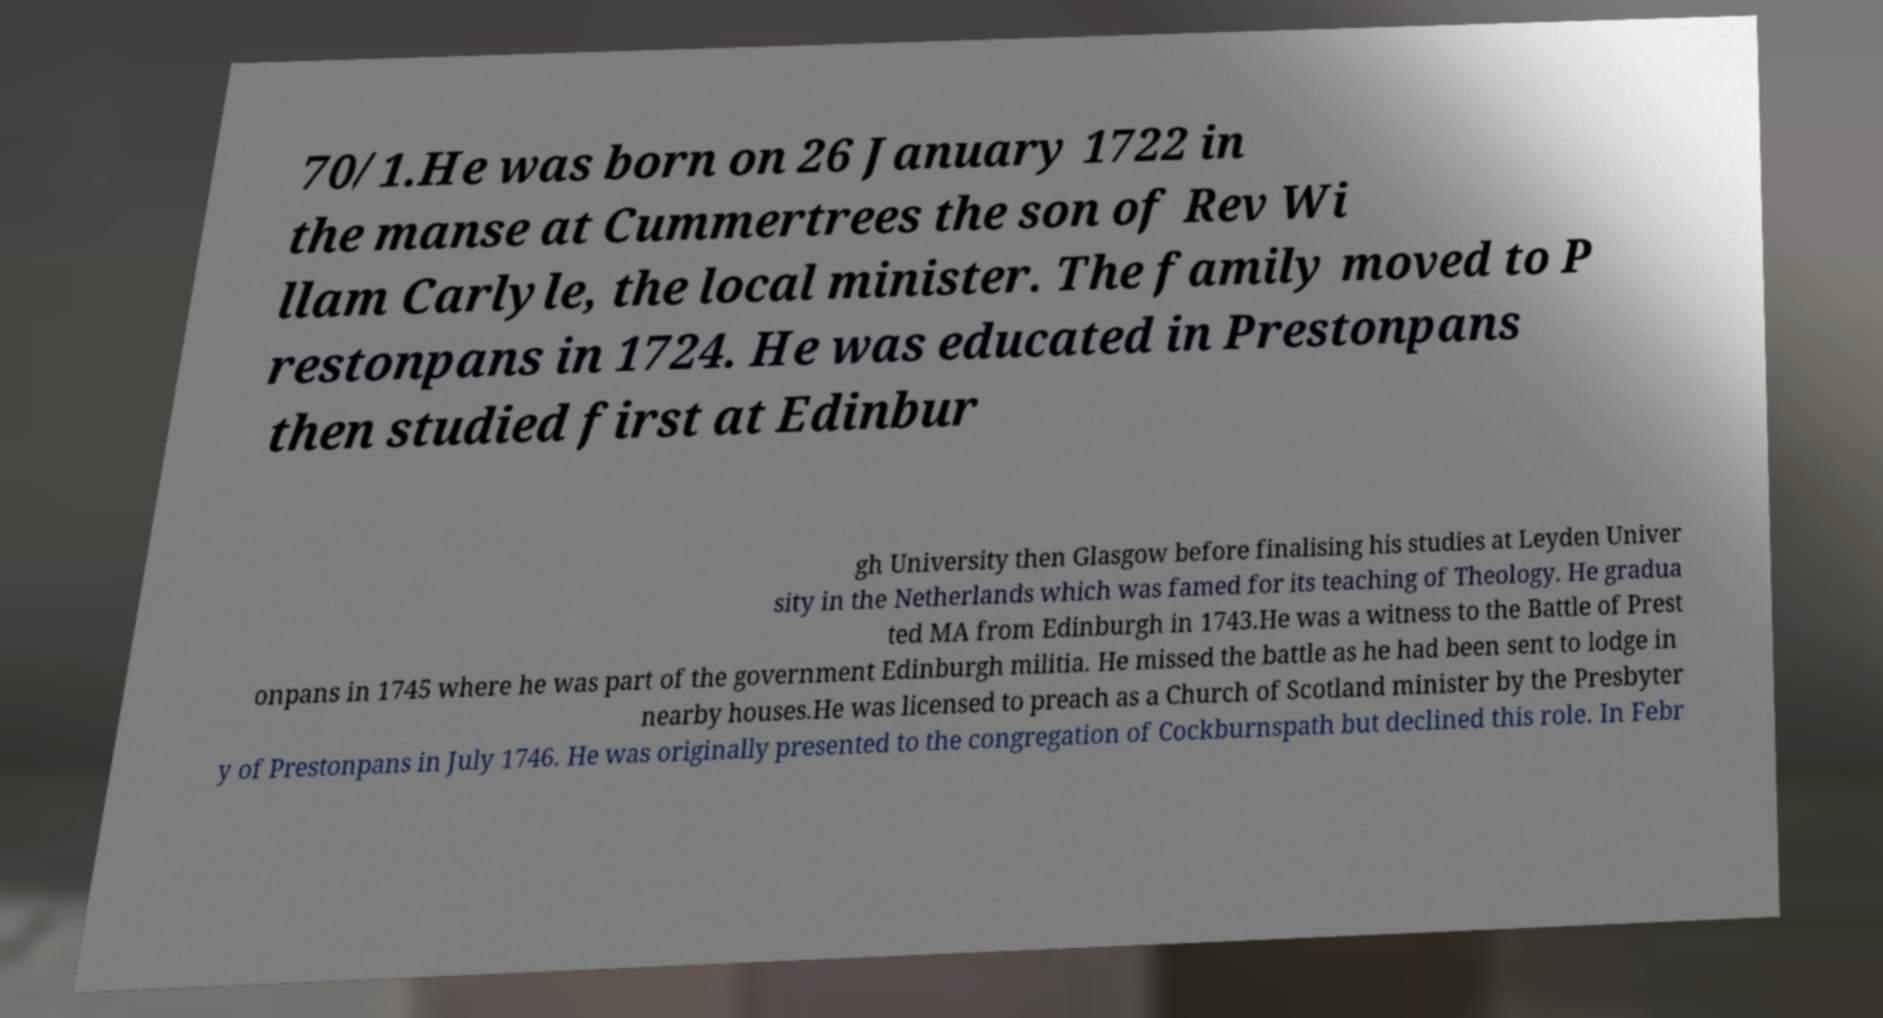Could you extract and type out the text from this image? 70/1.He was born on 26 January 1722 in the manse at Cummertrees the son of Rev Wi llam Carlyle, the local minister. The family moved to P restonpans in 1724. He was educated in Prestonpans then studied first at Edinbur gh University then Glasgow before finalising his studies at Leyden Univer sity in the Netherlands which was famed for its teaching of Theology. He gradua ted MA from Edinburgh in 1743.He was a witness to the Battle of Prest onpans in 1745 where he was part of the government Edinburgh militia. He missed the battle as he had been sent to lodge in nearby houses.He was licensed to preach as a Church of Scotland minister by the Presbyter y of Prestonpans in July 1746. He was originally presented to the congregation of Cockburnspath but declined this role. In Febr 